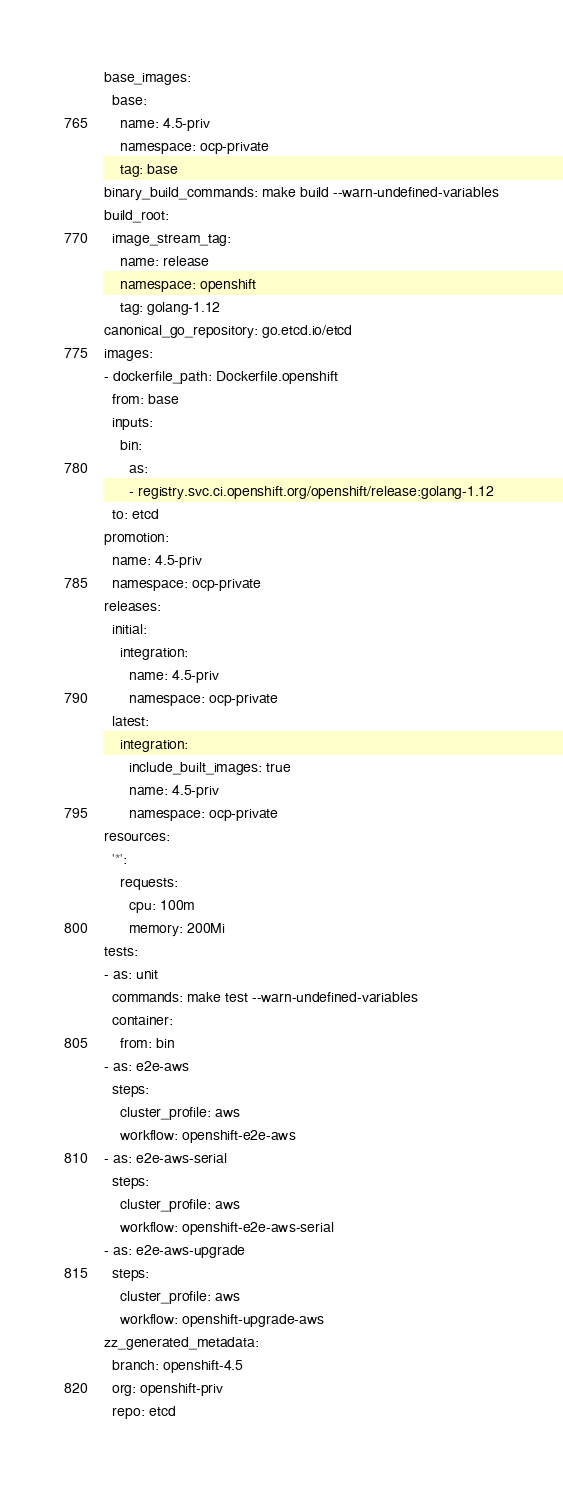<code> <loc_0><loc_0><loc_500><loc_500><_YAML_>base_images:
  base:
    name: 4.5-priv
    namespace: ocp-private
    tag: base
binary_build_commands: make build --warn-undefined-variables
build_root:
  image_stream_tag:
    name: release
    namespace: openshift
    tag: golang-1.12
canonical_go_repository: go.etcd.io/etcd
images:
- dockerfile_path: Dockerfile.openshift
  from: base
  inputs:
    bin:
      as:
      - registry.svc.ci.openshift.org/openshift/release:golang-1.12
  to: etcd
promotion:
  name: 4.5-priv
  namespace: ocp-private
releases:
  initial:
    integration:
      name: 4.5-priv
      namespace: ocp-private
  latest:
    integration:
      include_built_images: true
      name: 4.5-priv
      namespace: ocp-private
resources:
  '*':
    requests:
      cpu: 100m
      memory: 200Mi
tests:
- as: unit
  commands: make test --warn-undefined-variables
  container:
    from: bin
- as: e2e-aws
  steps:
    cluster_profile: aws
    workflow: openshift-e2e-aws
- as: e2e-aws-serial
  steps:
    cluster_profile: aws
    workflow: openshift-e2e-aws-serial
- as: e2e-aws-upgrade
  steps:
    cluster_profile: aws
    workflow: openshift-upgrade-aws
zz_generated_metadata:
  branch: openshift-4.5
  org: openshift-priv
  repo: etcd
</code> 